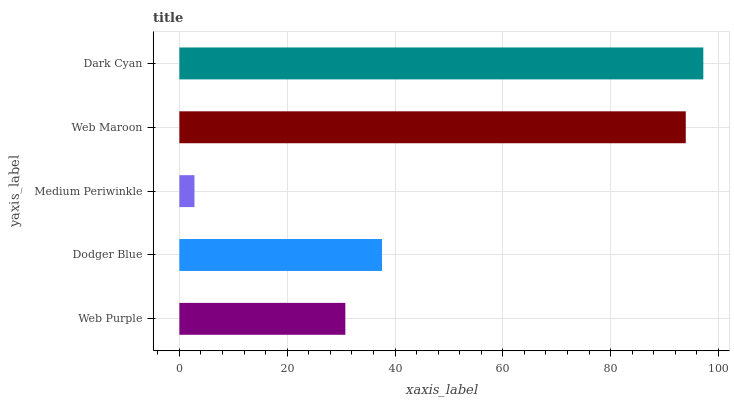Is Medium Periwinkle the minimum?
Answer yes or no. Yes. Is Dark Cyan the maximum?
Answer yes or no. Yes. Is Dodger Blue the minimum?
Answer yes or no. No. Is Dodger Blue the maximum?
Answer yes or no. No. Is Dodger Blue greater than Web Purple?
Answer yes or no. Yes. Is Web Purple less than Dodger Blue?
Answer yes or no. Yes. Is Web Purple greater than Dodger Blue?
Answer yes or no. No. Is Dodger Blue less than Web Purple?
Answer yes or no. No. Is Dodger Blue the high median?
Answer yes or no. Yes. Is Dodger Blue the low median?
Answer yes or no. Yes. Is Dark Cyan the high median?
Answer yes or no. No. Is Web Purple the low median?
Answer yes or no. No. 